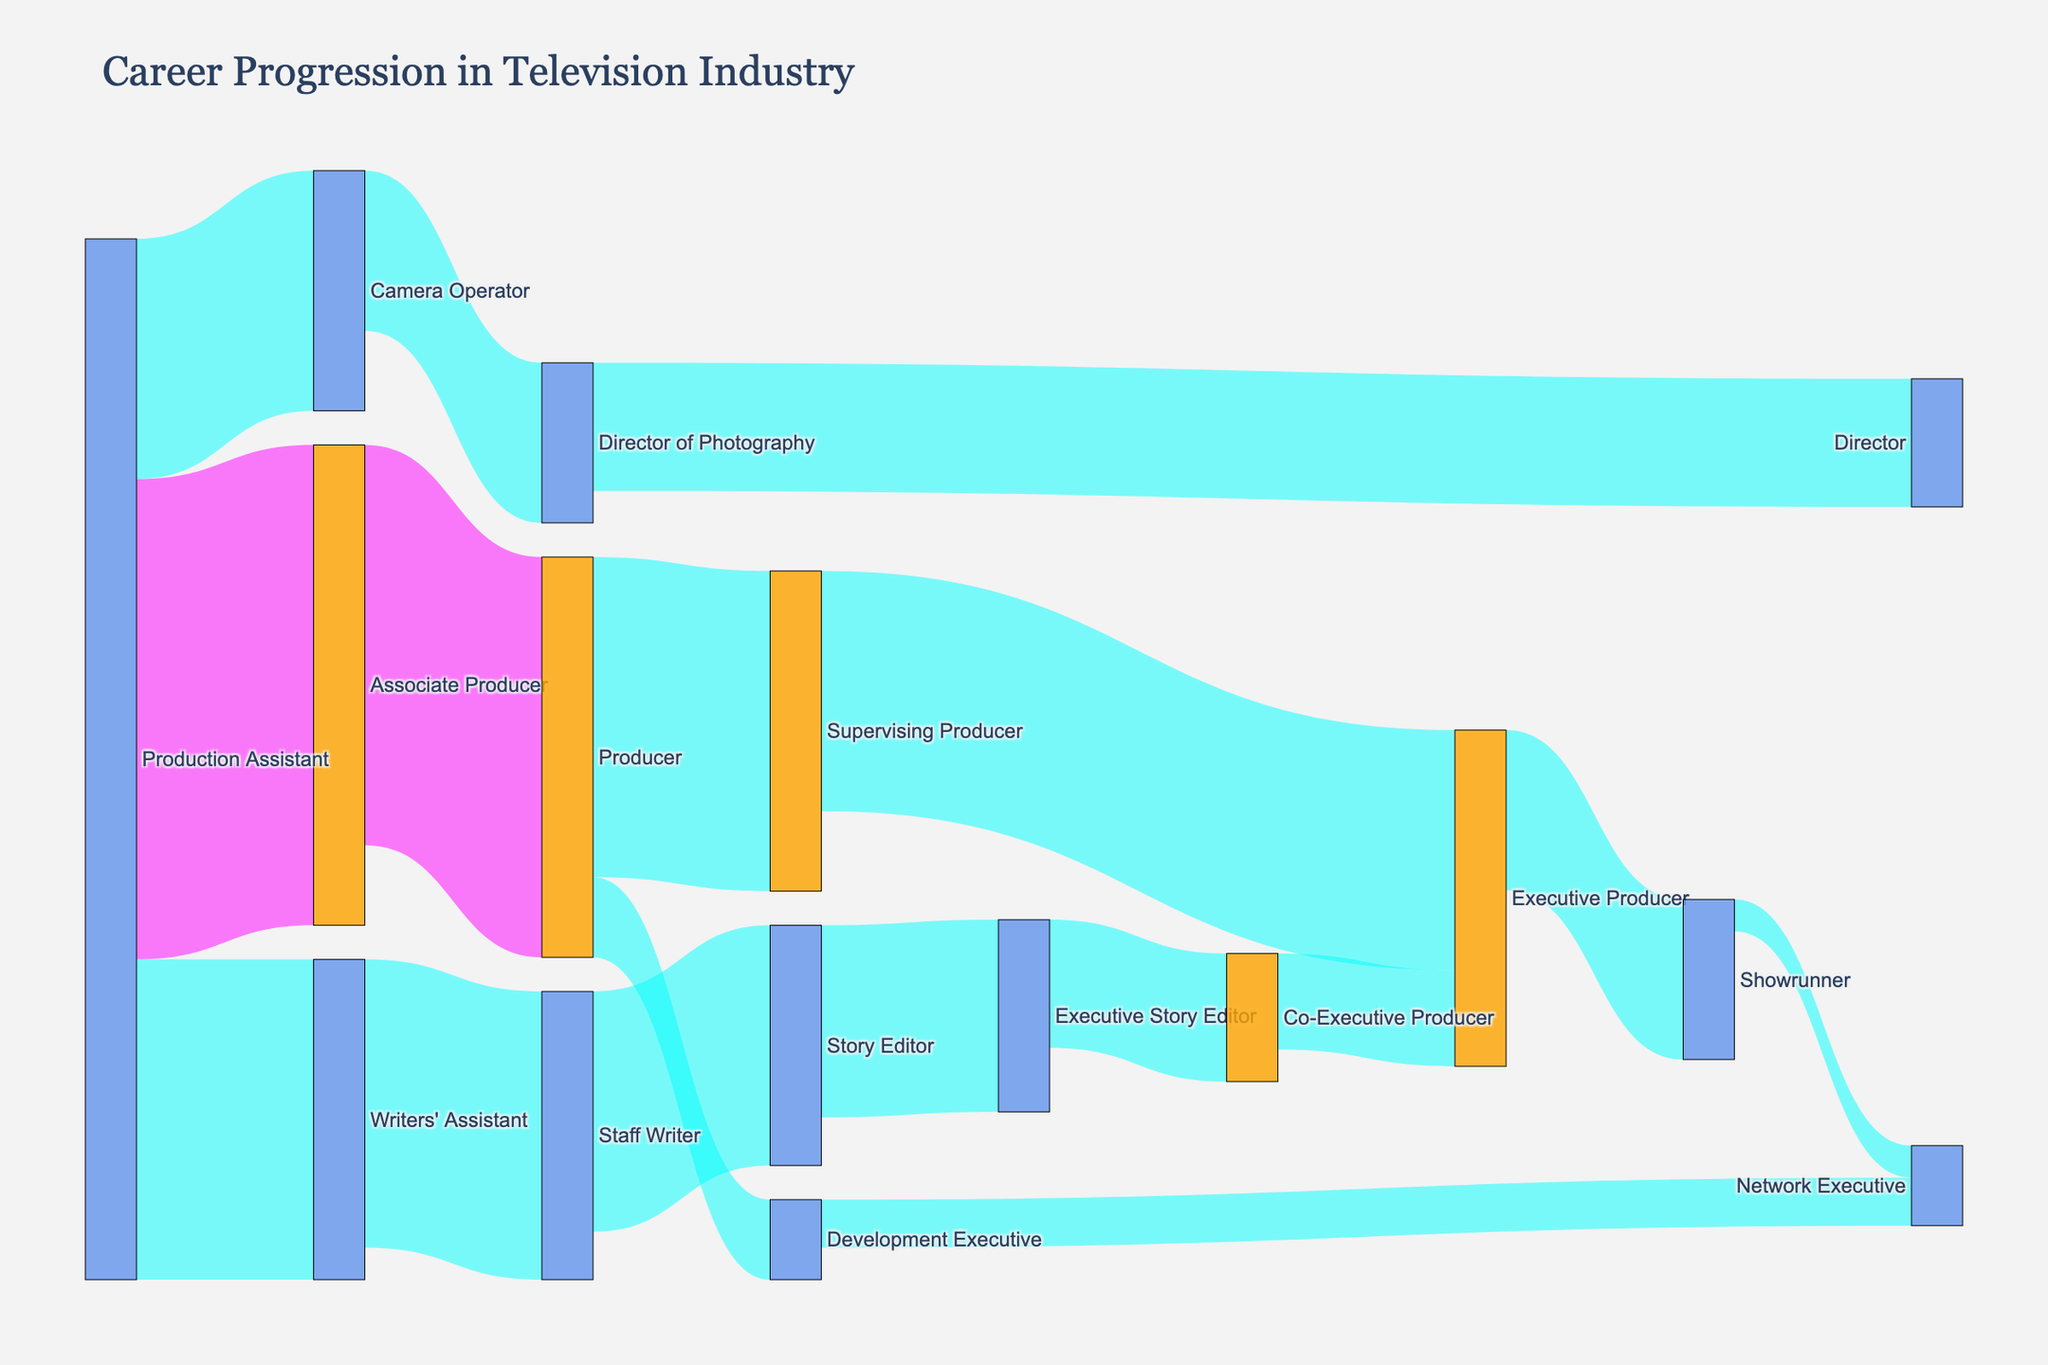What is the main title of the diagram? The main title of the diagram is usually prominently displayed at the top of the figure for quick identification. In this case, you can find the title "Career Progression in Television Industry" at the top of the figure.
Answer: Career Progression in Television Industry Which career path has the highest number of transitions from one role to another? The flow with the highest value represents the most transitions. In this diagram, the flow from "Production Assistant" to "Associate Producer" has the highest value of 30.
Answer: Production Assistant to Associate Producer How many people progressed from "Producer" to "Development Executive"? To find the number of people transitioning from "Producer" to "Development Executive," look for the corresponding flow in the diagram. The value shown is 5.
Answer: 5 What role does "Staff Writer" typically progress to next? By examining the flows originating from "Staff Writer," you can see where the majority of transitions go. The diagram shows "Staff Writer" progressing to "Story Editor" with a value of 15.
Answer: Story Editor Compare the number of people moving from "Executive Story Editor" to "Co-Executive Producer" with those moving from "Supervising Producer" to "Executive Producer." Which is higher? Check the values of the respective flows in the diagram. The value from "Executive Story Editor" to "Co-Executive Producer" is 8, while the value from "Supervising Producer" to "Executive Producer" is 15. The latter is higher.
Answer: Supervising Producer to Executive Producer Which roles lead to becoming an "Executive Producer"? Trace the paths leading to "Executive Producer" in the diagram. Both "Supervising Producer" and "Co-Executive Producer" lead to "Executive Producer," with values of 15 and 6, respectively.
Answer: Supervising Producer, Co-Executive Producer How many distinct career roles are visualized in the diagram? Count the unique career roles depicted as nodes in the diagram. By listing them out, you count 16 distinct roles.
Answer: 16 What is the total number of people who progress from a "Production Assistant" to other roles? Sum the values of all flows that originate from "Production Assistant.” These values are 30 (to Associate Producer), 20 (to Writers' Assistant), and 15 (to Camera Operator), totaling 65.
Answer: 65 Identify the end roles (roles where no further transitions are shown) in the diagram. End roles can be identified by finding nodes with no outgoing flows. These roles are "Director,” "Showrunner," "Network Executive," and "Executive Producer."
Answer: Director, Showrunner, Network Executive, Executive Producer Are there more people transitioning into "Executive Producer" or "Network Executive"? Compare the incoming flows to both roles. "Executive Producer" receives 15 (from Supervising Producer) + 6 (from Co-Executive Producer) = 21. "Network Executive" receives 3 (from Development Executive) + 2 (from Showrunner) = 5. Therefore, more people transition into "Executive Producer."
Answer: Executive Producer 